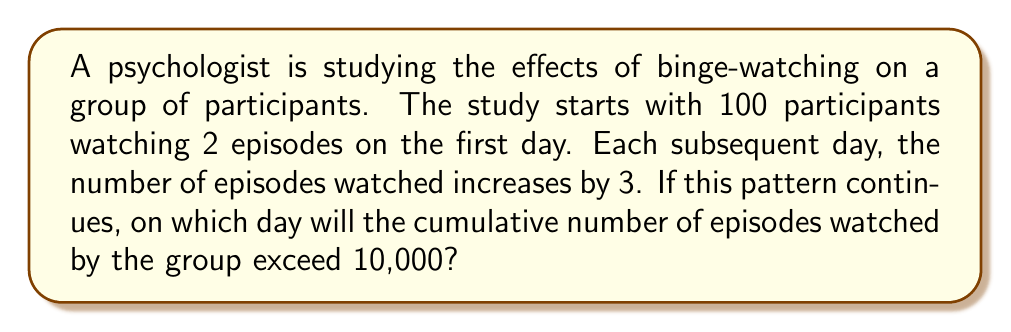Show me your answer to this math problem. Let's approach this step-by-step:

1) First, we need to recognize that this forms an arithmetic sequence. The number of episodes watched each day follows the pattern:

   $a_n = a_1 + (n-1)d$

   Where $a_1 = 2$ (first term), $d = 3$ (common difference), and $n$ is the day number.

2) The number of episodes watched on each day:
   Day 1: $2$
   Day 2: $2 + 3 = 5$
   Day 3: $2 + 2(3) = 8$
   Day 4: $2 + 3(3) = 11$
   And so on...

3) To find the cumulative number of episodes, we need the sum of this arithmetic sequence. The formula for the sum of an arithmetic sequence is:

   $S_n = \frac{n}{2}(a_1 + a_n) = \frac{n}{2}(2a_1 + (n-1)d)$

4) Substituting our values:

   $S_n = \frac{n}{2}(2(2) + (n-1)3) = \frac{n}{2}(4 + 3n - 3) = \frac{n}{2}(3n + 1)$

5) We need to find $n$ where $S_n > 10000$:

   $\frac{n}{2}(3n + 1) > 10000$
   $3n^2 + n > 20000$
   $3n^2 + n - 20000 > 0$

6) This is a quadratic inequality. We can solve it using the quadratic formula:

   $n = \frac{-1 \pm \sqrt{1^2 - 4(3)(-20000)}}{2(3)}$

7) Solving this:

   $n \approx 81.65$ or $n \approx -81.99$

8) Since we're dealing with days, we need the positive solution. And since we're looking for the day it exceeds 10,000, we need to round up.

Therefore, it will exceed 10,000 on day 82.
Answer: 82 days 